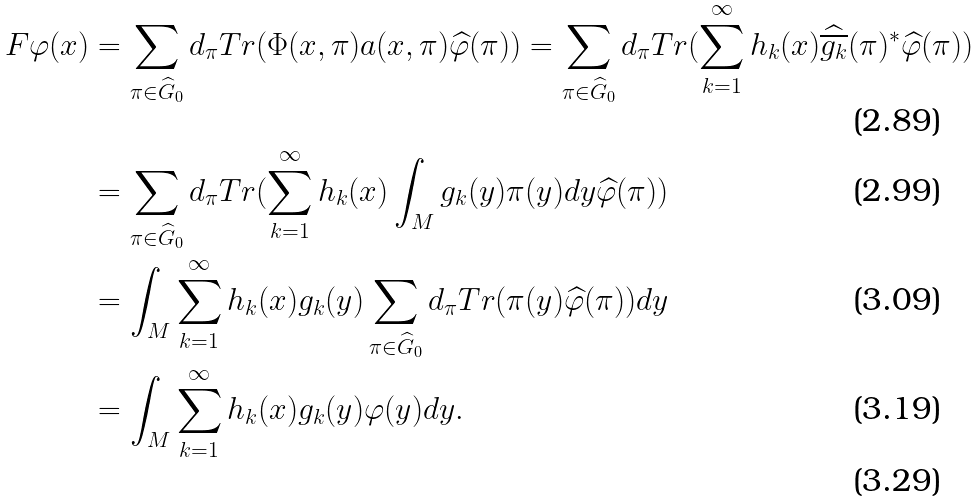Convert formula to latex. <formula><loc_0><loc_0><loc_500><loc_500>F \varphi ( x ) & = \sum _ { \pi \in \widehat { G } _ { 0 } } d _ { \pi } T r ( \Phi ( x , \pi ) a ( x , \pi ) \widehat { \varphi } ( \pi ) ) = \sum _ { \pi \in \widehat { G } _ { 0 } } d _ { \pi } T r ( \sum _ { k = 1 } ^ { \infty } h _ { k } ( x ) \widehat { \overline { g _ { k } } } ( \pi ) ^ { * } \widehat { \varphi } ( \pi ) ) \\ & = \sum _ { \pi \in \widehat { G } _ { 0 } } d _ { \pi } T r ( \sum _ { k = 1 } ^ { \infty } h _ { k } ( x ) \int _ { M } g _ { k } ( y ) \pi ( y ) d y \widehat { \varphi } ( \pi ) ) \\ & = \int _ { M } \sum _ { k = 1 } ^ { \infty } h _ { k } ( x ) g _ { k } ( y ) \sum _ { \pi \in \widehat { G } _ { 0 } } d _ { \pi } T r ( \pi ( y ) \widehat { \varphi } ( \pi ) ) d y \\ & = \int _ { M } \sum _ { k = 1 } ^ { \infty } h _ { k } ( x ) g _ { k } ( y ) \varphi ( y ) d y . \\</formula> 